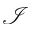Convert formula to latex. <formula><loc_0><loc_0><loc_500><loc_500>\mathcal { I }</formula> 